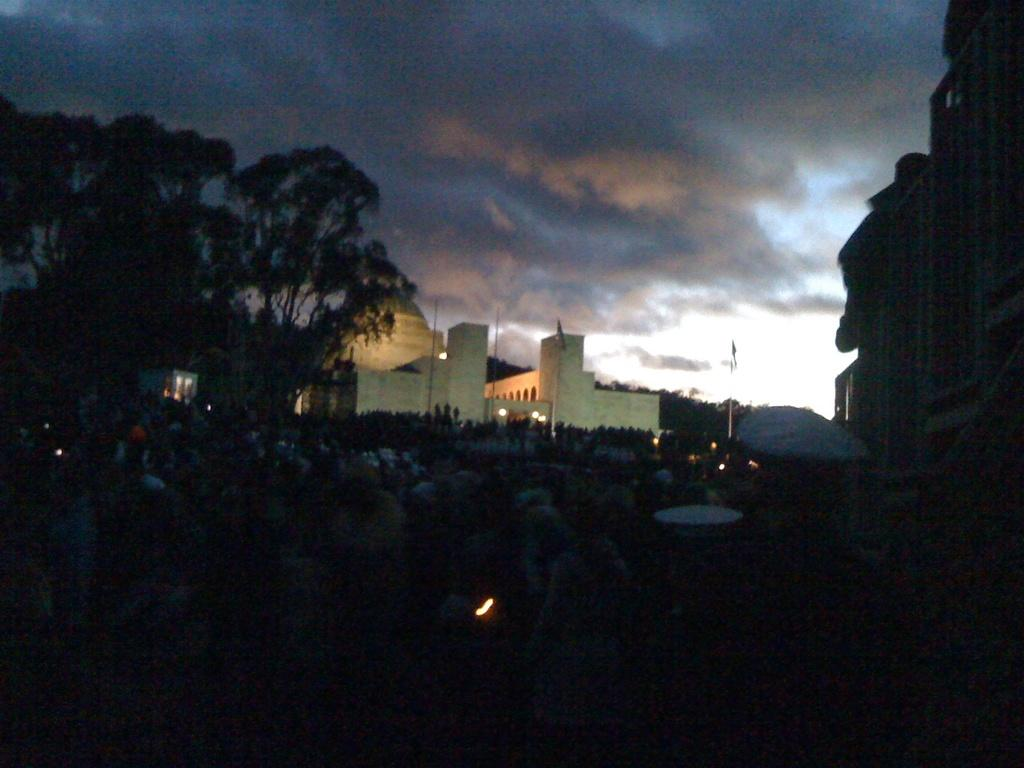What type of structures can be seen in the image? There are buildings in the image. What other natural elements are present in the image? There are trees in the image. What decorations can be seen hanging from poles? There are flags hanging from poles in the image. Are there any people visible in the image? Yes, there are people standing in the image. What can be seen in the sky in the image? There are clouds visible in the sky. What type of pancake is being served to the people in the image? There is no pancake present in the image; it features buildings, trees, flags, people, and clouds. What color is the vest worn by the person standing in the image? There is no person wearing a vest in the image. 